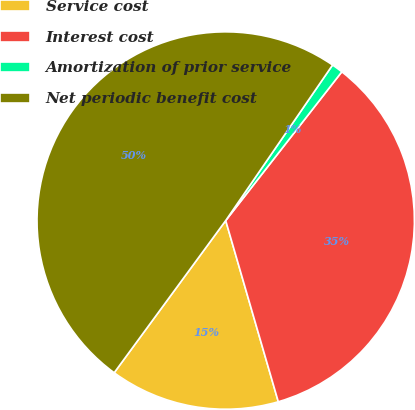Convert chart. <chart><loc_0><loc_0><loc_500><loc_500><pie_chart><fcel>Service cost<fcel>Interest cost<fcel>Amortization of prior service<fcel>Net periodic benefit cost<nl><fcel>14.56%<fcel>34.95%<fcel>0.97%<fcel>49.51%<nl></chart> 